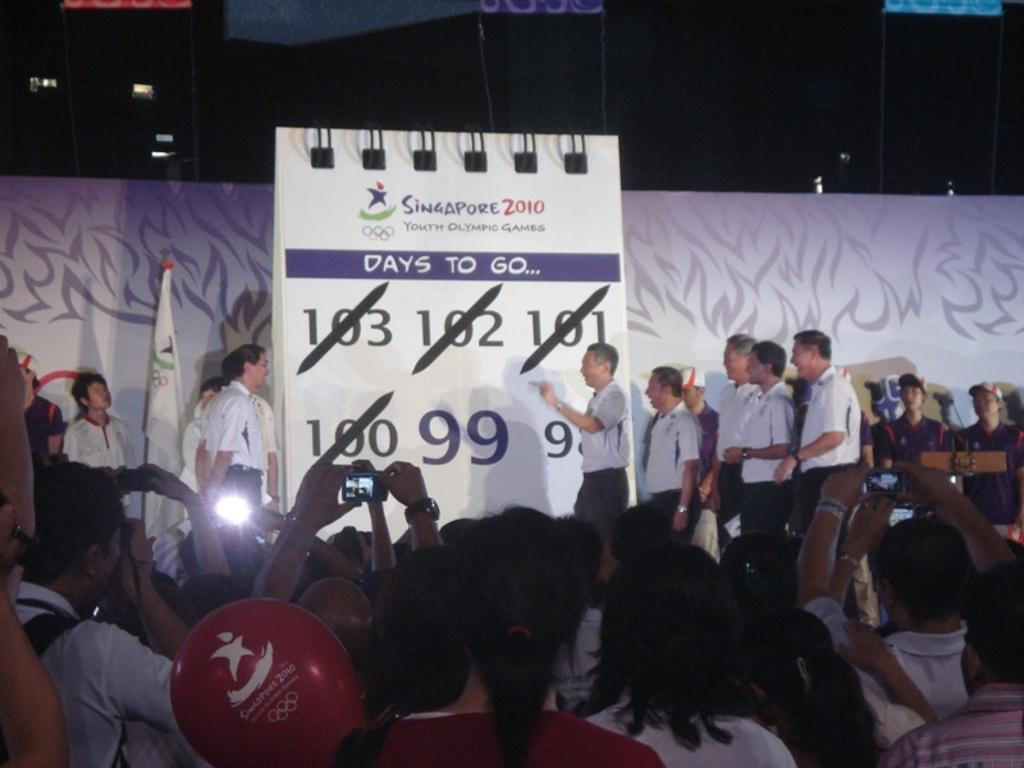What are the people in the image doing? There are people standing in the image, and some of them are holding cameras in their hands. What can be seen in the background of the image? There is a flag in the image. What object might be used for keeping track of dates and events? There is a calendar in the image. What type of headwear is worn by some people in the image? Some people are wearing caps on their heads. What type of metal is used to make the debt visible in the image? There is no mention of debt or metal in the image; it only features people, cameras, a flag, a calendar, and caps. 